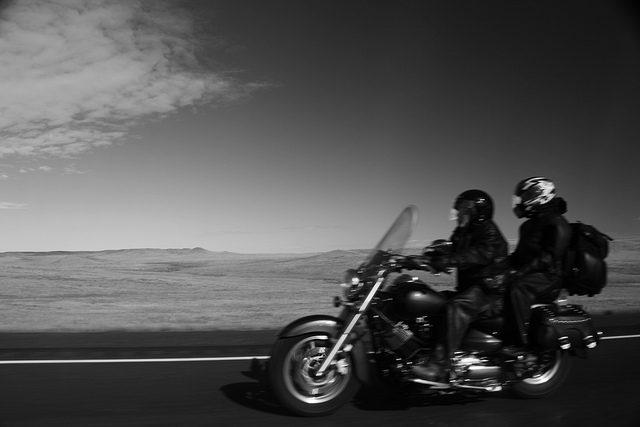What mood does the black-and-white color scheme of this image evoke? The black-and-white color scheme of the image evokes a nostalgic and timeless mood, emphasizing the classic and enduring appeal of motorcycle touring. It strips away the distractions of color, focusing the viewer on the textures, contrasts, and essence of the journey and landscape. 